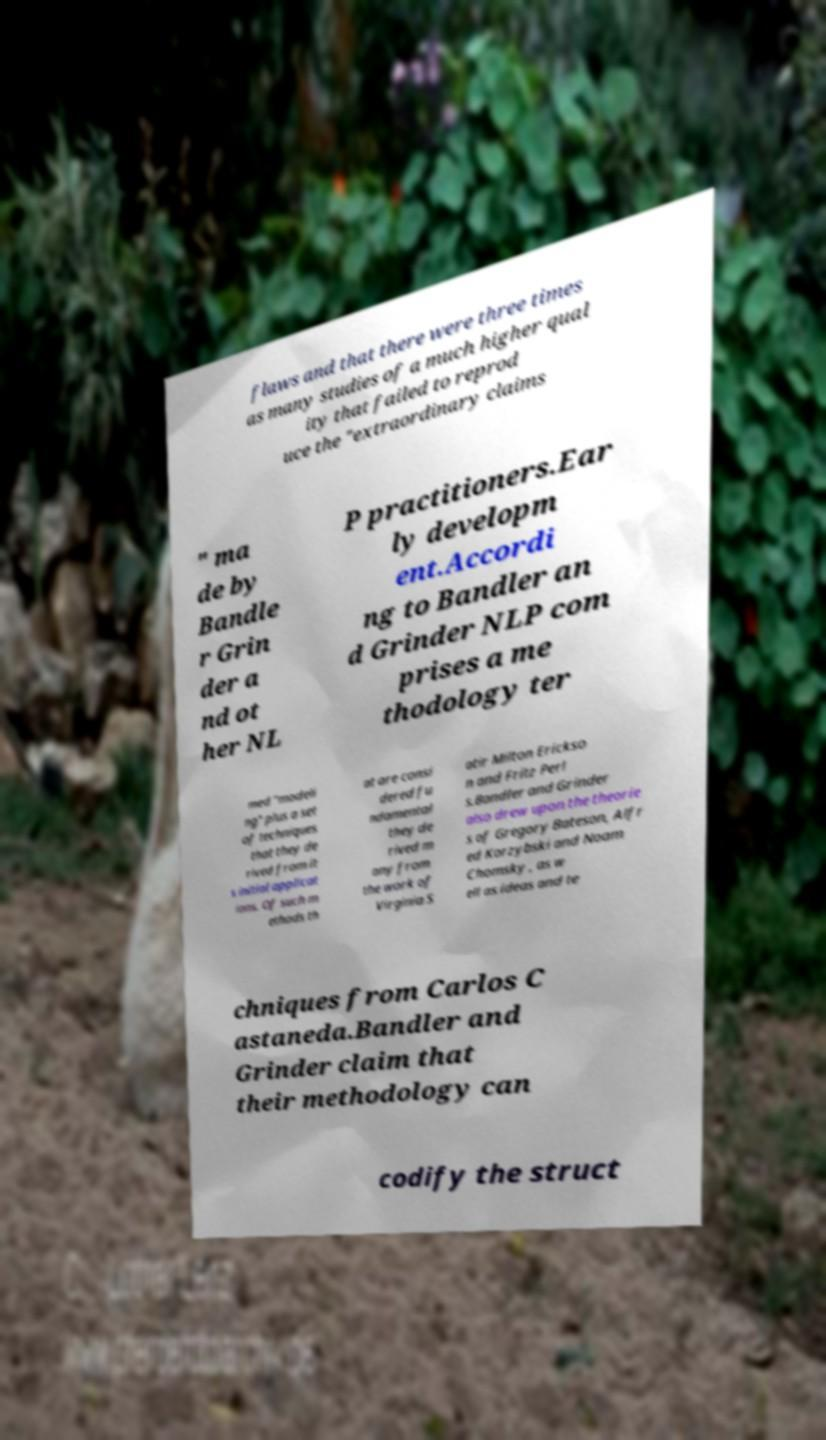For documentation purposes, I need the text within this image transcribed. Could you provide that? flaws and that there were three times as many studies of a much higher qual ity that failed to reprod uce the "extraordinary claims " ma de by Bandle r Grin der a nd ot her NL P practitioners.Ear ly developm ent.Accordi ng to Bandler an d Grinder NLP com prises a me thodology ter med "modeli ng" plus a set of techniques that they de rived from it s initial applicat ions. Of such m ethods th at are consi dered fu ndamental they de rived m any from the work of Virginia S atir Milton Erickso n and Fritz Perl s.Bandler and Grinder also drew upon the theorie s of Gregory Bateson, Alfr ed Korzybski and Noam Chomsky , as w ell as ideas and te chniques from Carlos C astaneda.Bandler and Grinder claim that their methodology can codify the struct 